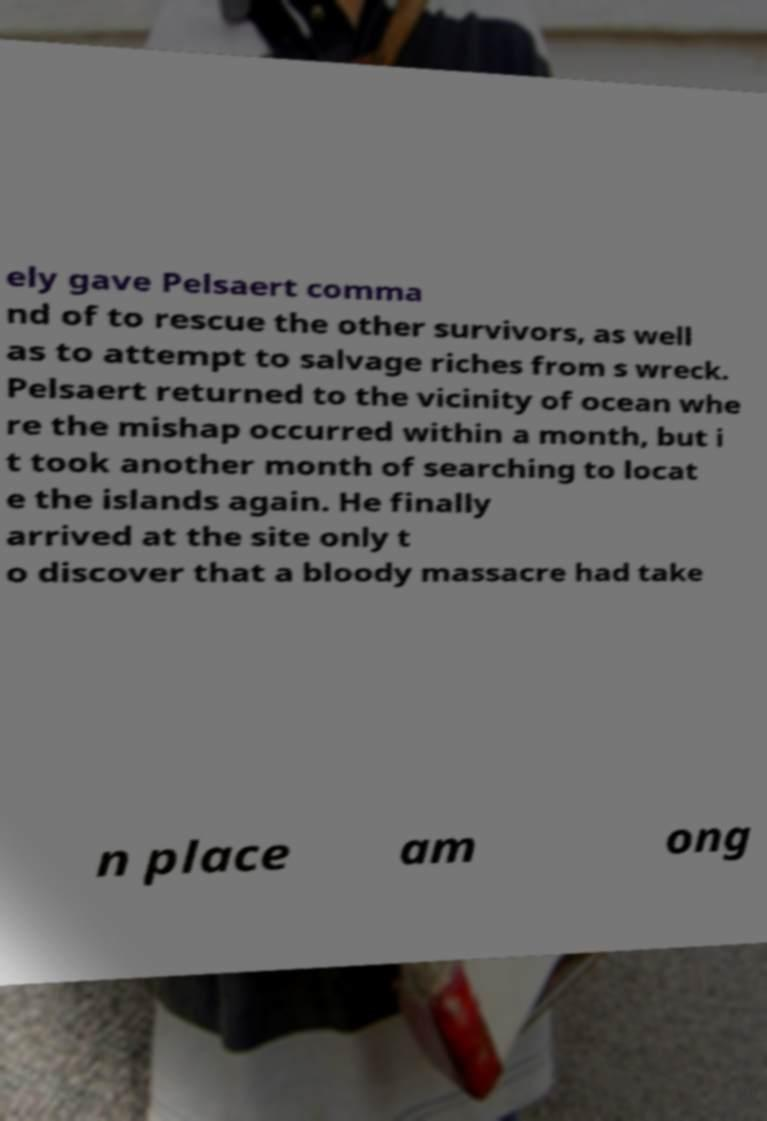There's text embedded in this image that I need extracted. Can you transcribe it verbatim? ely gave Pelsaert comma nd of to rescue the other survivors, as well as to attempt to salvage riches from s wreck. Pelsaert returned to the vicinity of ocean whe re the mishap occurred within a month, but i t took another month of searching to locat e the islands again. He finally arrived at the site only t o discover that a bloody massacre had take n place am ong 